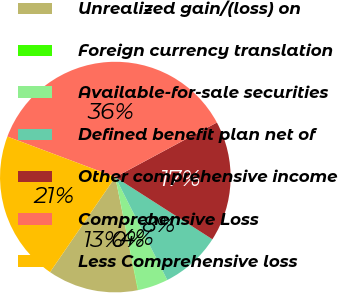Convert chart to OTSL. <chart><loc_0><loc_0><loc_500><loc_500><pie_chart><fcel>Unrealized gain/(loss) on<fcel>Foreign currency translation<fcel>Available-for-sale securities<fcel>Defined benefit plan net of<fcel>Other comprehensive income<fcel>Comprehensive Loss<fcel>Less Comprehensive loss<nl><fcel>12.7%<fcel>0.05%<fcel>4.27%<fcel>8.49%<fcel>16.92%<fcel>36.44%<fcel>21.14%<nl></chart> 